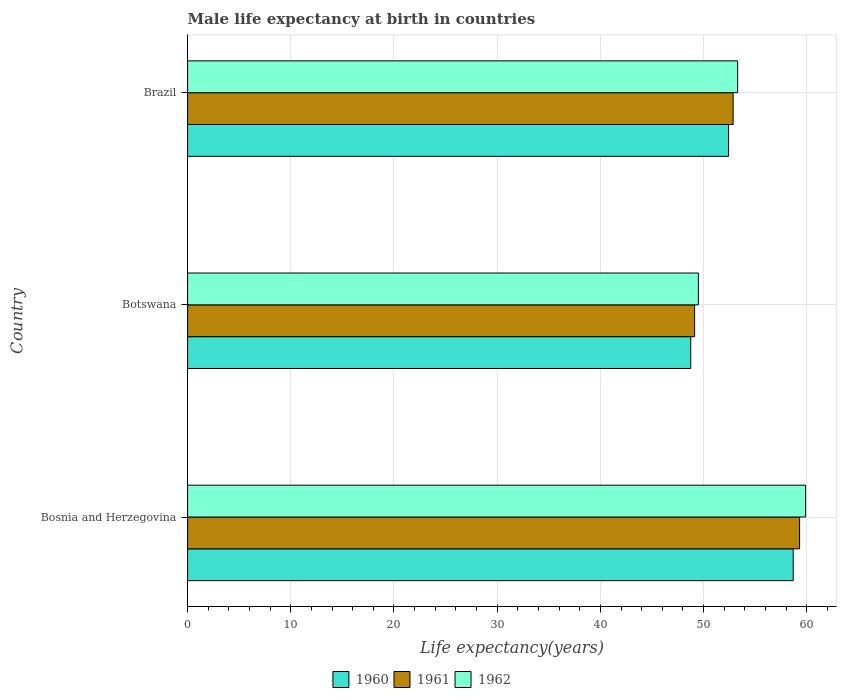How many different coloured bars are there?
Provide a succinct answer. 3. Are the number of bars per tick equal to the number of legend labels?
Give a very brief answer. Yes. Are the number of bars on each tick of the Y-axis equal?
Make the answer very short. Yes. How many bars are there on the 2nd tick from the top?
Your answer should be very brief. 3. What is the label of the 3rd group of bars from the top?
Your answer should be very brief. Bosnia and Herzegovina. What is the male life expectancy at birth in 1962 in Bosnia and Herzegovina?
Ensure brevity in your answer.  59.89. Across all countries, what is the maximum male life expectancy at birth in 1960?
Your answer should be very brief. 58.69. Across all countries, what is the minimum male life expectancy at birth in 1960?
Your answer should be compact. 48.76. In which country was the male life expectancy at birth in 1960 maximum?
Offer a very short reply. Bosnia and Herzegovina. In which country was the male life expectancy at birth in 1962 minimum?
Offer a terse response. Botswana. What is the total male life expectancy at birth in 1962 in the graph?
Keep it short and to the point. 162.69. What is the difference between the male life expectancy at birth in 1962 in Bosnia and Herzegovina and that in Botswana?
Offer a terse response. 10.39. What is the difference between the male life expectancy at birth in 1962 in Bosnia and Herzegovina and the male life expectancy at birth in 1961 in Botswana?
Your response must be concise. 10.75. What is the average male life expectancy at birth in 1962 per country?
Offer a very short reply. 54.23. What is the difference between the male life expectancy at birth in 1962 and male life expectancy at birth in 1960 in Bosnia and Herzegovina?
Offer a terse response. 1.2. What is the ratio of the male life expectancy at birth in 1962 in Bosnia and Herzegovina to that in Brazil?
Offer a terse response. 1.12. What is the difference between the highest and the second highest male life expectancy at birth in 1962?
Give a very brief answer. 6.59. What is the difference between the highest and the lowest male life expectancy at birth in 1960?
Provide a short and direct response. 9.93. In how many countries, is the male life expectancy at birth in 1960 greater than the average male life expectancy at birth in 1960 taken over all countries?
Keep it short and to the point. 1. What does the 1st bar from the bottom in Bosnia and Herzegovina represents?
Ensure brevity in your answer.  1960. How many bars are there?
Keep it short and to the point. 9. How many countries are there in the graph?
Your response must be concise. 3. What is the difference between two consecutive major ticks on the X-axis?
Your response must be concise. 10. Does the graph contain any zero values?
Provide a short and direct response. No. Where does the legend appear in the graph?
Provide a short and direct response. Bottom center. What is the title of the graph?
Keep it short and to the point. Male life expectancy at birth in countries. What is the label or title of the X-axis?
Your response must be concise. Life expectancy(years). What is the Life expectancy(years) in 1960 in Bosnia and Herzegovina?
Provide a short and direct response. 58.69. What is the Life expectancy(years) in 1961 in Bosnia and Herzegovina?
Your answer should be compact. 59.3. What is the Life expectancy(years) in 1962 in Bosnia and Herzegovina?
Give a very brief answer. 59.89. What is the Life expectancy(years) in 1960 in Botswana?
Make the answer very short. 48.76. What is the Life expectancy(years) of 1961 in Botswana?
Your response must be concise. 49.13. What is the Life expectancy(years) of 1962 in Botswana?
Your answer should be very brief. 49.5. What is the Life expectancy(years) in 1960 in Brazil?
Your answer should be compact. 52.42. What is the Life expectancy(years) in 1961 in Brazil?
Provide a short and direct response. 52.87. What is the Life expectancy(years) of 1962 in Brazil?
Your answer should be very brief. 53.3. Across all countries, what is the maximum Life expectancy(years) of 1960?
Ensure brevity in your answer.  58.69. Across all countries, what is the maximum Life expectancy(years) of 1961?
Give a very brief answer. 59.3. Across all countries, what is the maximum Life expectancy(years) of 1962?
Keep it short and to the point. 59.89. Across all countries, what is the minimum Life expectancy(years) in 1960?
Your response must be concise. 48.76. Across all countries, what is the minimum Life expectancy(years) in 1961?
Your response must be concise. 49.13. Across all countries, what is the minimum Life expectancy(years) in 1962?
Give a very brief answer. 49.5. What is the total Life expectancy(years) of 1960 in the graph?
Your response must be concise. 159.87. What is the total Life expectancy(years) of 1961 in the graph?
Provide a succinct answer. 161.31. What is the total Life expectancy(years) of 1962 in the graph?
Provide a short and direct response. 162.69. What is the difference between the Life expectancy(years) in 1960 in Bosnia and Herzegovina and that in Botswana?
Keep it short and to the point. 9.93. What is the difference between the Life expectancy(years) of 1961 in Bosnia and Herzegovina and that in Botswana?
Offer a very short reply. 10.17. What is the difference between the Life expectancy(years) in 1962 in Bosnia and Herzegovina and that in Botswana?
Your response must be concise. 10.39. What is the difference between the Life expectancy(years) in 1960 in Bosnia and Herzegovina and that in Brazil?
Offer a very short reply. 6.26. What is the difference between the Life expectancy(years) of 1961 in Bosnia and Herzegovina and that in Brazil?
Your response must be concise. 6.44. What is the difference between the Life expectancy(years) in 1962 in Bosnia and Herzegovina and that in Brazil?
Give a very brief answer. 6.58. What is the difference between the Life expectancy(years) of 1960 in Botswana and that in Brazil?
Your answer should be compact. -3.67. What is the difference between the Life expectancy(years) in 1961 in Botswana and that in Brazil?
Make the answer very short. -3.73. What is the difference between the Life expectancy(years) of 1962 in Botswana and that in Brazil?
Provide a succinct answer. -3.81. What is the difference between the Life expectancy(years) of 1960 in Bosnia and Herzegovina and the Life expectancy(years) of 1961 in Botswana?
Provide a short and direct response. 9.55. What is the difference between the Life expectancy(years) of 1960 in Bosnia and Herzegovina and the Life expectancy(years) of 1962 in Botswana?
Offer a terse response. 9.19. What is the difference between the Life expectancy(years) in 1961 in Bosnia and Herzegovina and the Life expectancy(years) in 1962 in Botswana?
Offer a very short reply. 9.81. What is the difference between the Life expectancy(years) in 1960 in Bosnia and Herzegovina and the Life expectancy(years) in 1961 in Brazil?
Provide a succinct answer. 5.82. What is the difference between the Life expectancy(years) in 1960 in Bosnia and Herzegovina and the Life expectancy(years) in 1962 in Brazil?
Your answer should be very brief. 5.38. What is the difference between the Life expectancy(years) in 1961 in Bosnia and Herzegovina and the Life expectancy(years) in 1962 in Brazil?
Give a very brief answer. 6. What is the difference between the Life expectancy(years) of 1960 in Botswana and the Life expectancy(years) of 1961 in Brazil?
Your response must be concise. -4.11. What is the difference between the Life expectancy(years) of 1960 in Botswana and the Life expectancy(years) of 1962 in Brazil?
Give a very brief answer. -4.54. What is the difference between the Life expectancy(years) of 1961 in Botswana and the Life expectancy(years) of 1962 in Brazil?
Keep it short and to the point. -4.17. What is the average Life expectancy(years) in 1960 per country?
Make the answer very short. 53.29. What is the average Life expectancy(years) of 1961 per country?
Keep it short and to the point. 53.77. What is the average Life expectancy(years) of 1962 per country?
Keep it short and to the point. 54.23. What is the difference between the Life expectancy(years) of 1960 and Life expectancy(years) of 1961 in Bosnia and Herzegovina?
Make the answer very short. -0.62. What is the difference between the Life expectancy(years) of 1960 and Life expectancy(years) of 1962 in Bosnia and Herzegovina?
Your response must be concise. -1.2. What is the difference between the Life expectancy(years) of 1961 and Life expectancy(years) of 1962 in Bosnia and Herzegovina?
Keep it short and to the point. -0.58. What is the difference between the Life expectancy(years) of 1960 and Life expectancy(years) of 1961 in Botswana?
Provide a succinct answer. -0.38. What is the difference between the Life expectancy(years) of 1960 and Life expectancy(years) of 1962 in Botswana?
Offer a very short reply. -0.74. What is the difference between the Life expectancy(years) in 1961 and Life expectancy(years) in 1962 in Botswana?
Your answer should be compact. -0.36. What is the difference between the Life expectancy(years) in 1960 and Life expectancy(years) in 1961 in Brazil?
Your answer should be compact. -0.44. What is the difference between the Life expectancy(years) of 1960 and Life expectancy(years) of 1962 in Brazil?
Make the answer very short. -0.88. What is the difference between the Life expectancy(years) in 1961 and Life expectancy(years) in 1962 in Brazil?
Ensure brevity in your answer.  -0.43. What is the ratio of the Life expectancy(years) in 1960 in Bosnia and Herzegovina to that in Botswana?
Give a very brief answer. 1.2. What is the ratio of the Life expectancy(years) of 1961 in Bosnia and Herzegovina to that in Botswana?
Offer a very short reply. 1.21. What is the ratio of the Life expectancy(years) of 1962 in Bosnia and Herzegovina to that in Botswana?
Your response must be concise. 1.21. What is the ratio of the Life expectancy(years) of 1960 in Bosnia and Herzegovina to that in Brazil?
Offer a very short reply. 1.12. What is the ratio of the Life expectancy(years) of 1961 in Bosnia and Herzegovina to that in Brazil?
Keep it short and to the point. 1.12. What is the ratio of the Life expectancy(years) of 1962 in Bosnia and Herzegovina to that in Brazil?
Ensure brevity in your answer.  1.12. What is the ratio of the Life expectancy(years) in 1960 in Botswana to that in Brazil?
Offer a very short reply. 0.93. What is the ratio of the Life expectancy(years) of 1961 in Botswana to that in Brazil?
Your response must be concise. 0.93. What is the ratio of the Life expectancy(years) in 1962 in Botswana to that in Brazil?
Make the answer very short. 0.93. What is the difference between the highest and the second highest Life expectancy(years) in 1960?
Keep it short and to the point. 6.26. What is the difference between the highest and the second highest Life expectancy(years) of 1961?
Ensure brevity in your answer.  6.44. What is the difference between the highest and the second highest Life expectancy(years) of 1962?
Give a very brief answer. 6.58. What is the difference between the highest and the lowest Life expectancy(years) in 1960?
Your answer should be compact. 9.93. What is the difference between the highest and the lowest Life expectancy(years) of 1961?
Offer a very short reply. 10.17. What is the difference between the highest and the lowest Life expectancy(years) of 1962?
Your answer should be compact. 10.39. 